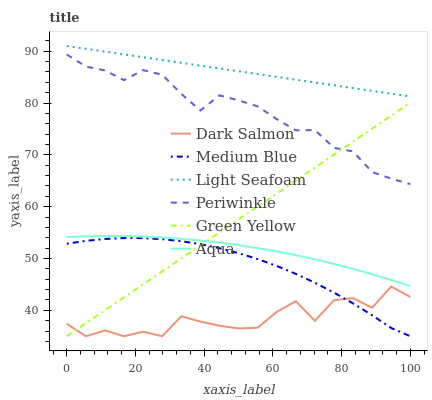Does Dark Salmon have the minimum area under the curve?
Answer yes or no. Yes. Does Light Seafoam have the maximum area under the curve?
Answer yes or no. Yes. Does Medium Blue have the minimum area under the curve?
Answer yes or no. No. Does Medium Blue have the maximum area under the curve?
Answer yes or no. No. Is Light Seafoam the smoothest?
Answer yes or no. Yes. Is Dark Salmon the roughest?
Answer yes or no. Yes. Is Medium Blue the smoothest?
Answer yes or no. No. Is Medium Blue the roughest?
Answer yes or no. No. Does Medium Blue have the lowest value?
Answer yes or no. Yes. Does Aqua have the lowest value?
Answer yes or no. No. Does Light Seafoam have the highest value?
Answer yes or no. Yes. Does Medium Blue have the highest value?
Answer yes or no. No. Is Dark Salmon less than Aqua?
Answer yes or no. Yes. Is Aqua greater than Dark Salmon?
Answer yes or no. Yes. Does Aqua intersect Green Yellow?
Answer yes or no. Yes. Is Aqua less than Green Yellow?
Answer yes or no. No. Is Aqua greater than Green Yellow?
Answer yes or no. No. Does Dark Salmon intersect Aqua?
Answer yes or no. No. 